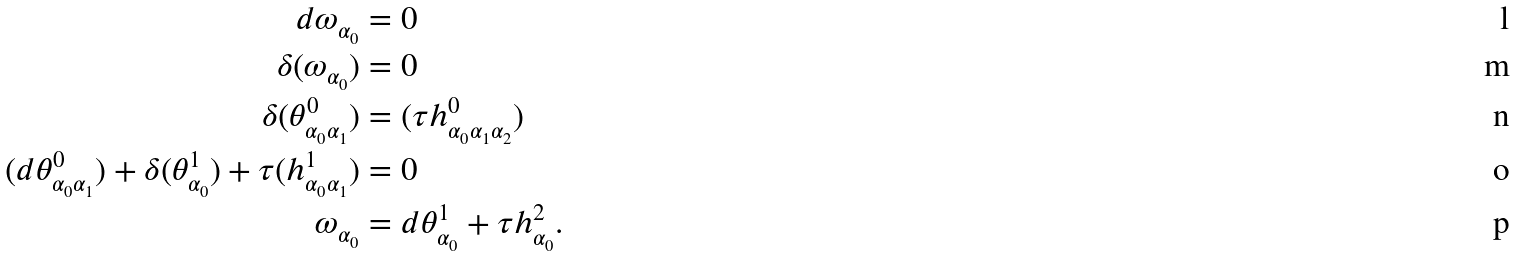Convert formula to latex. <formula><loc_0><loc_0><loc_500><loc_500>d \omega _ { \alpha _ { 0 } } & = 0 \\ \delta ( \omega _ { \alpha _ { 0 } } ) & = 0 \\ \delta ( \theta ^ { 0 } _ { \alpha _ { 0 } \alpha _ { 1 } } ) & = ( \tau h ^ { 0 } _ { \alpha _ { 0 } \alpha _ { 1 } \alpha _ { 2 } } ) \\ ( d \theta ^ { 0 } _ { \alpha _ { 0 } \alpha _ { 1 } } ) + \delta ( \theta ^ { 1 } _ { \alpha _ { 0 } } ) + \tau ( h ^ { 1 } _ { \alpha _ { 0 } \alpha _ { 1 } } ) & = 0 \\ \omega _ { \alpha _ { 0 } } & = d \theta ^ { 1 } _ { \alpha _ { 0 } } + \tau h ^ { 2 } _ { \alpha _ { 0 } } .</formula> 